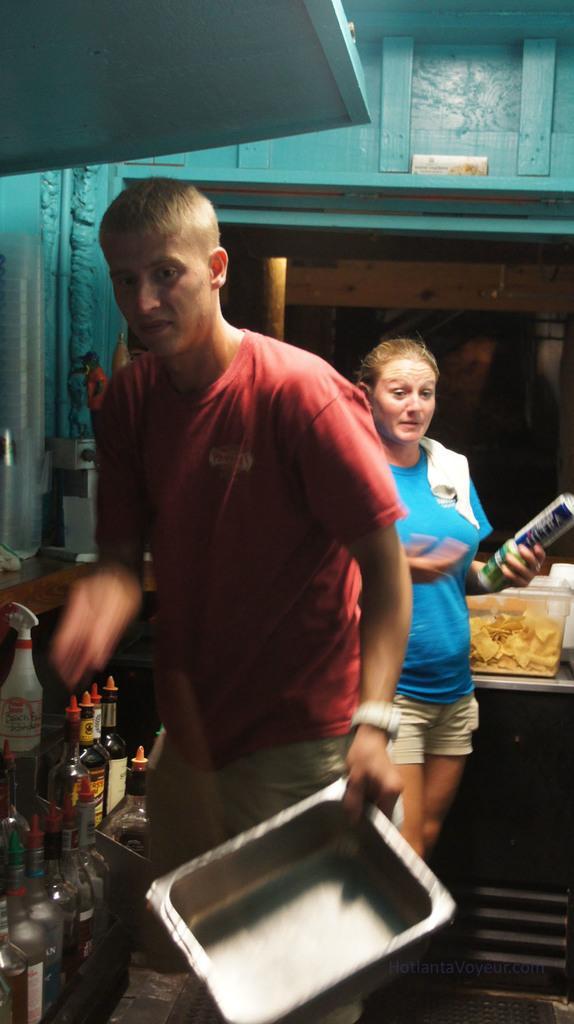Please provide a concise description of this image. There is a man and a woman. A man is holding a vessel. And the woman is holding something in the hand. On the left side there are bottles. In the back there is a basket with chips. In the background there is a wall. 